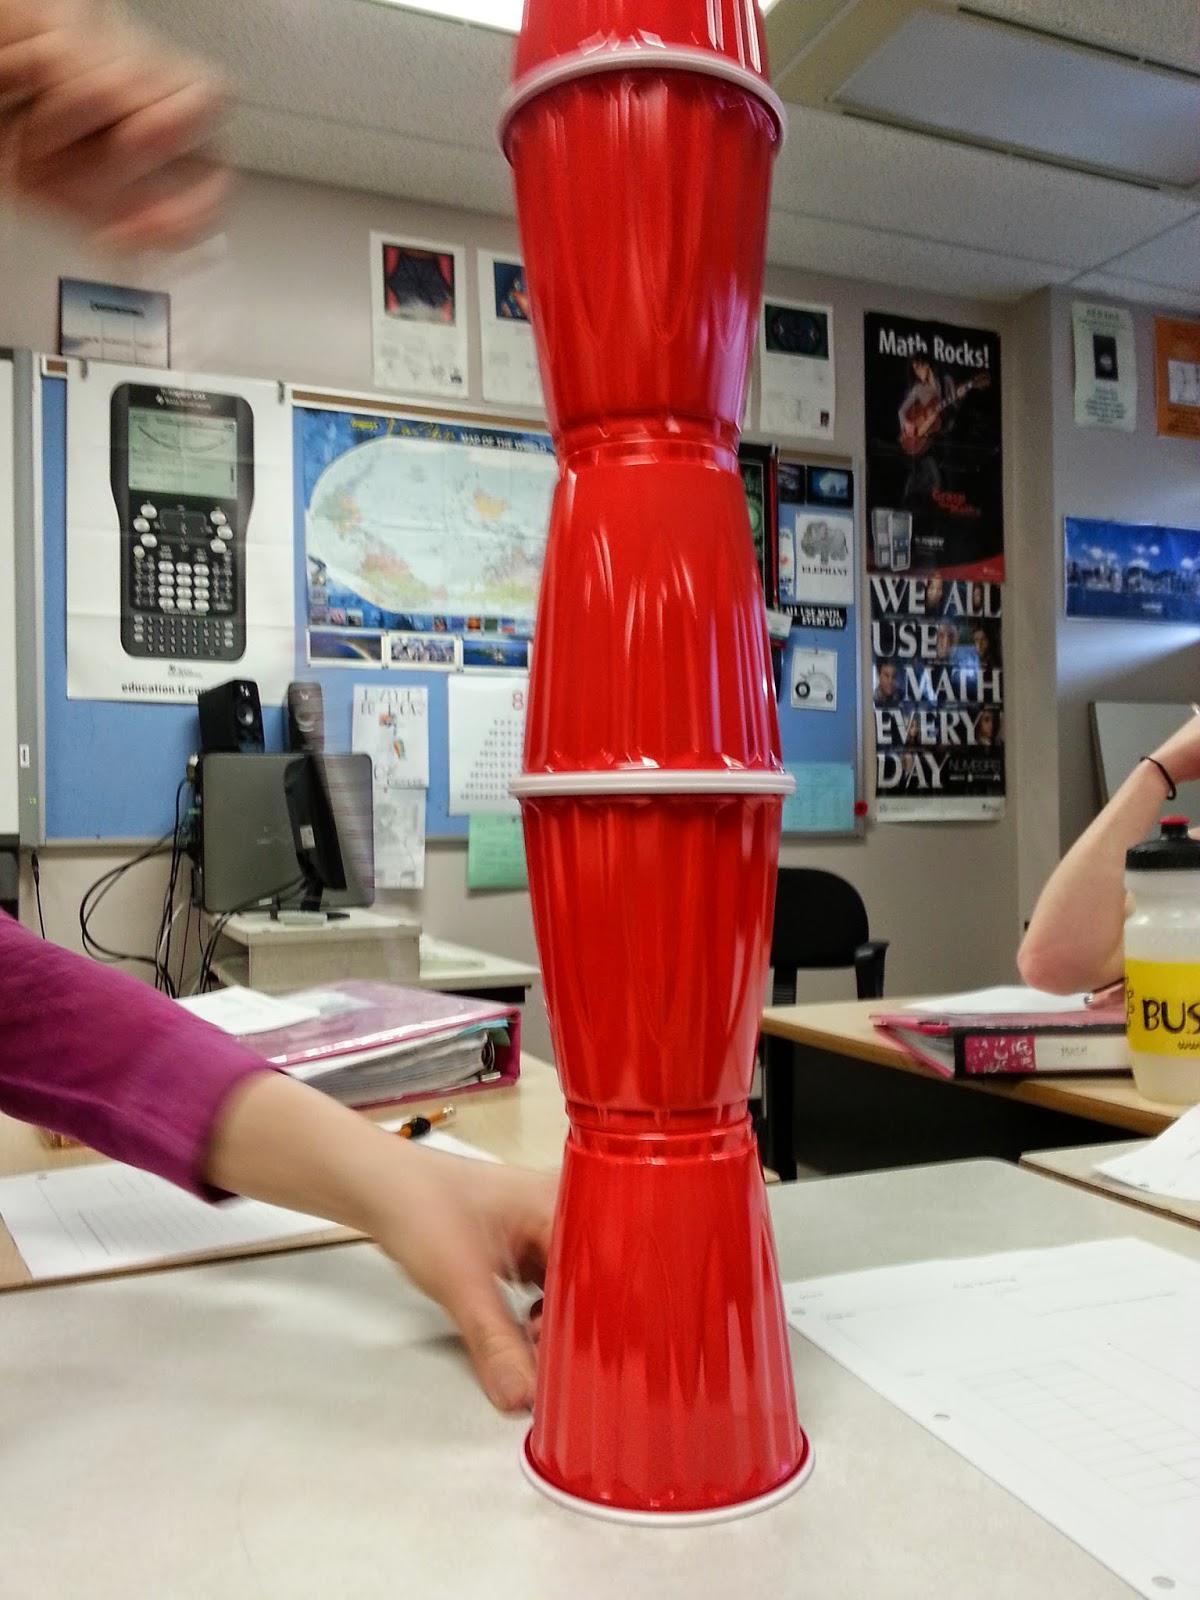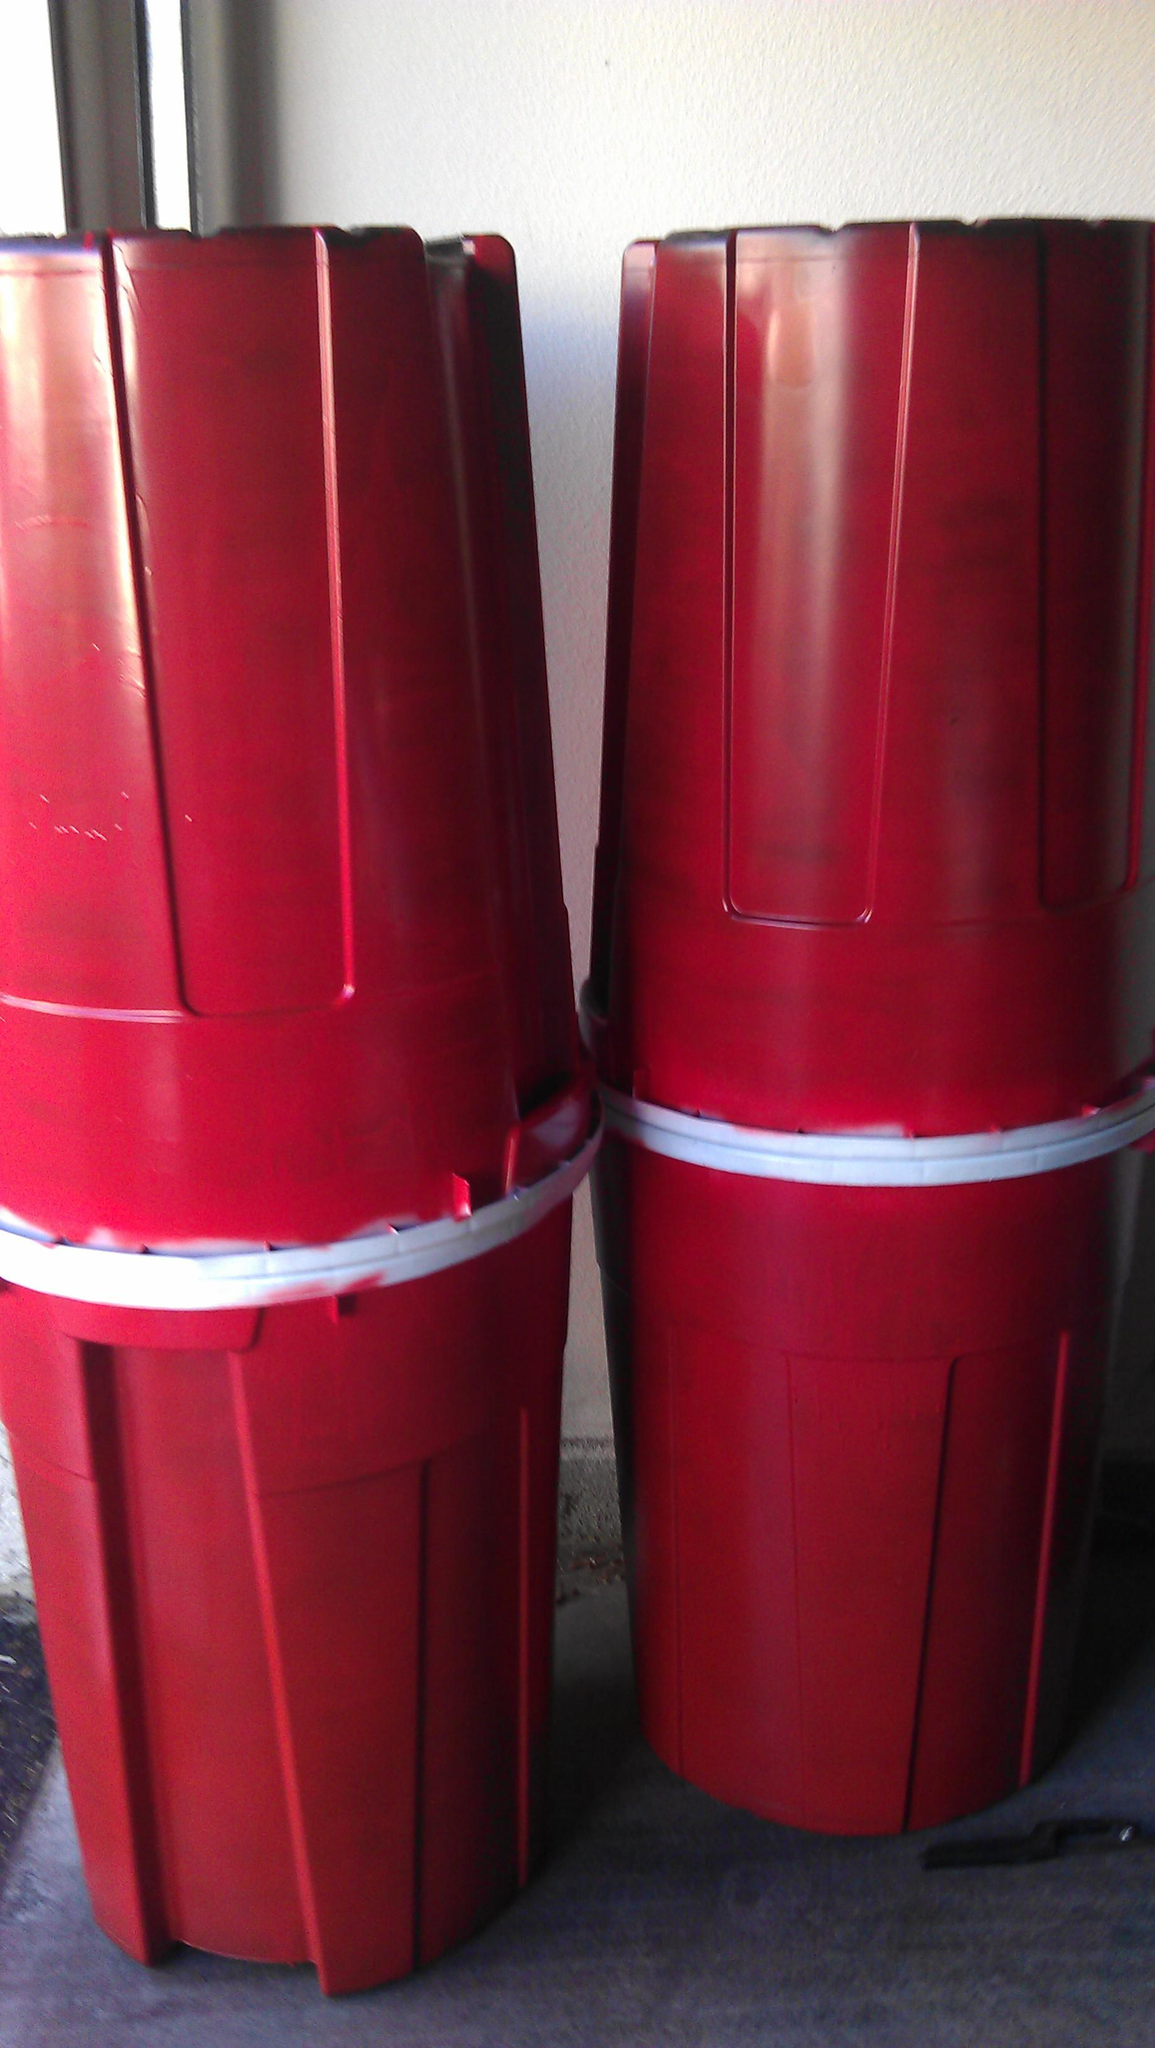The first image is the image on the left, the second image is the image on the right. For the images displayed, is the sentence "Several red solo cups are stacked nested neatly inside each other." factually correct? Answer yes or no. No. The first image is the image on the left, the second image is the image on the right. For the images shown, is this caption "The left image features a tower of five stacked red plastic cups, and the right image includes rightside-up and upside-down red cups shapes." true? Answer yes or no. Yes. 